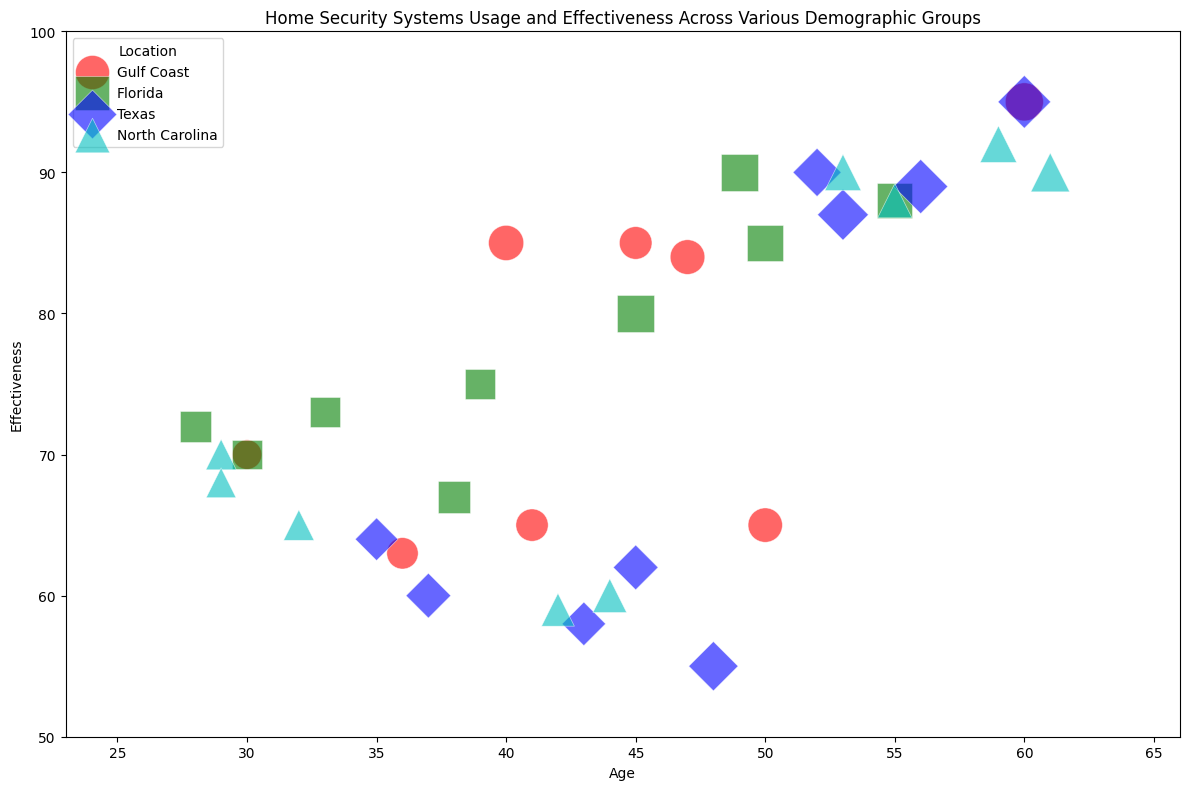What is the relationship between age and the effectiveness of home security systems in the Gulf Coast? Look at the Gulf Coast data points (marked with a specific marker and color) in the scatter plot. Notice the trend in the effectiveness scores as age increases.
Answer: As age increases, the effectiveness of home security systems generally improves in the Gulf Coast Which location has the highest average effectiveness for households with home security installed? Find the data points representing households with home security installed (effectiveness scores above 50) and calculate the average effectiveness for each location.
Answer: Texas Compare the effectiveness of home security systems for households aged 40-50 in Florida and Texas. Identify the data points for households in the age range 40-50 in both Florida and Texas. Compare their corresponding effectiveness values.
Answer: Florida tends to have slightly higher effectiveness in this age range Which location shows the largest variance in the effectiveness of home security systems? Determine the range of effectiveness values for each location by finding the difference between the highest and lowest effectiveness values for data points in each location.
Answer: Texas What is the general trend in home security effectiveness for households older than 50 years across all locations? Identify the data points for households older than 50 years across all locations and observe the pattern in their effectiveness scores.
Answer: The effectiveness tends to be higher for households older than 50 years across all locations How does income influence the effectiveness of home security systems for households in North Carolina? Look at the North Carolina data points and examine income levels represented by the sizes of the markers to assess if higher income correlates with higher effectiveness.
Answer: Higher income generally correlates with higher effectiveness in North Carolina Which age group in the Gulf Coast has the most varied effectiveness scores for home security systems? Review the Gulf Coast data points and identify the range of effectiveness scores for different age groups to determine the most varied group.
Answer: The 40-50 age group shows the most varied effectiveness scores How do the number of storms per year and home security effectiveness relate for households in Texas? Examine the data points for Texas and compare the storm frequency values to the effectiveness values to interpret any correlation.
Answer: Higher storm frequency generally correlates with higher effectiveness in Texas What is the average effectiveness of home security systems for middle-aged households (ages 30-50) across all locations? Identify the data points for ages 30-50 and calculate their average effectiveness by summing their effectiveness values and dividing by the number of data points.
Answer: Approximately 71 